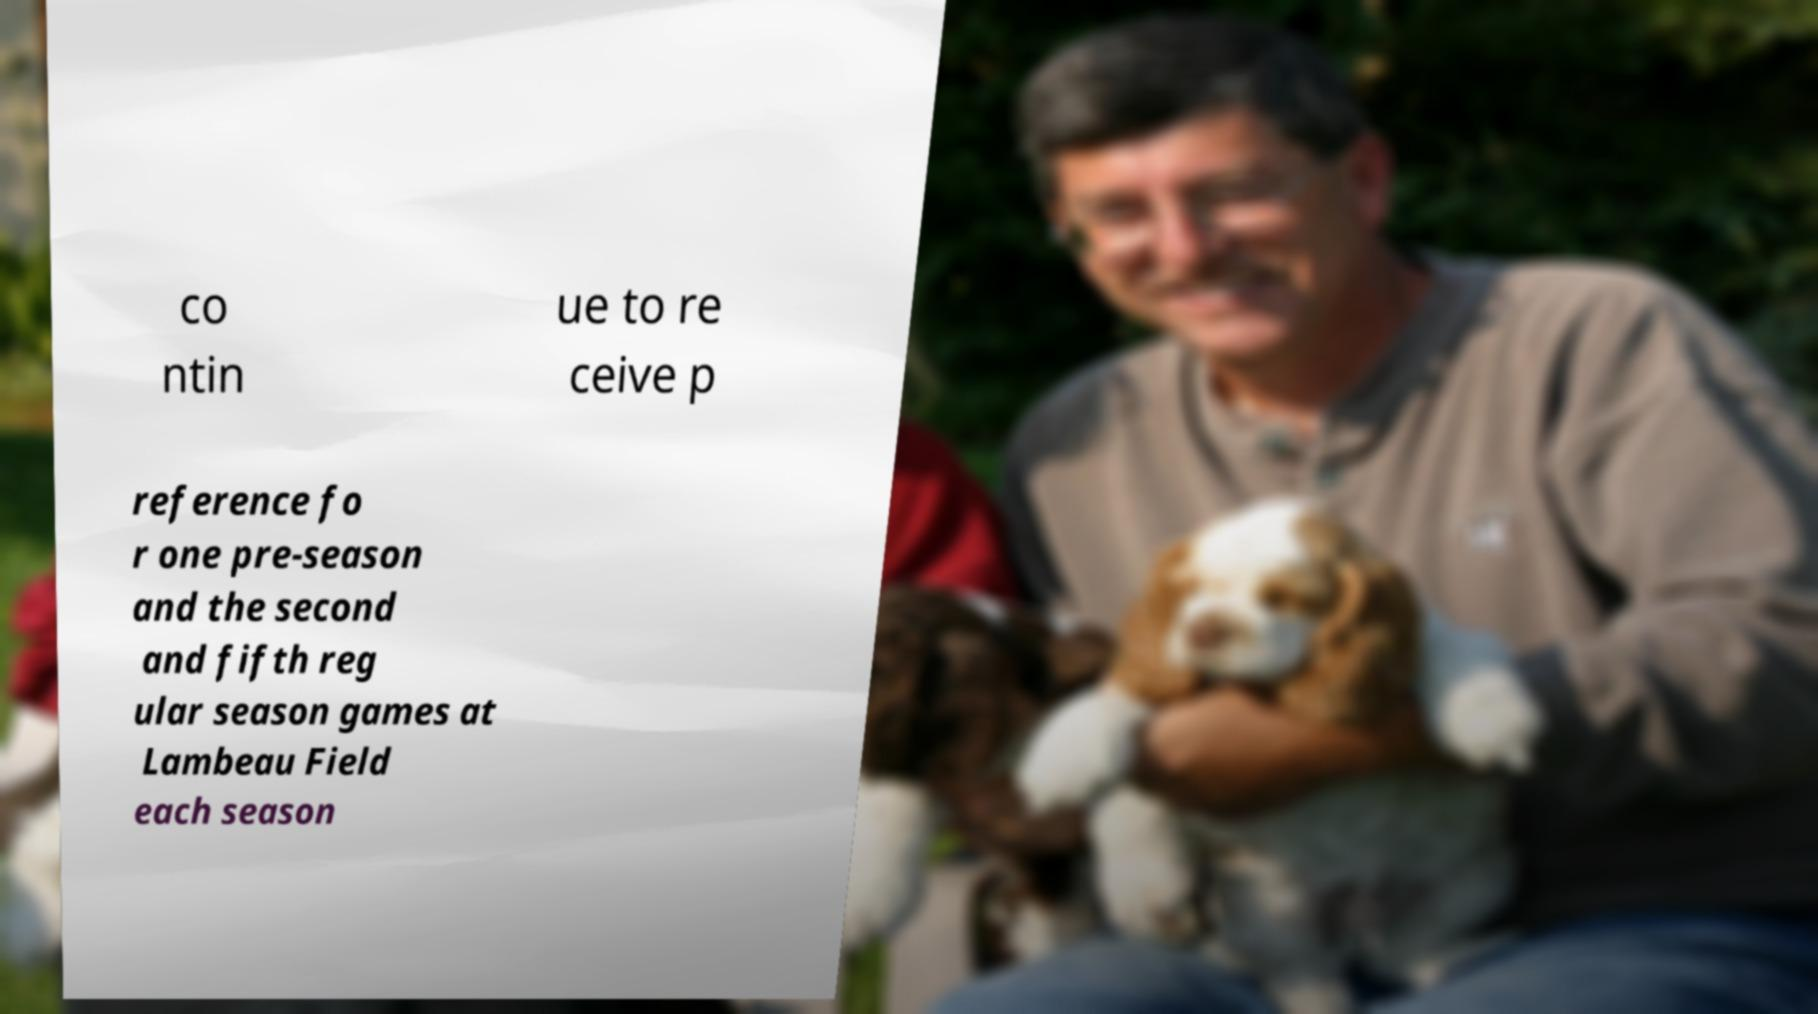What messages or text are displayed in this image? I need them in a readable, typed format. co ntin ue to re ceive p reference fo r one pre-season and the second and fifth reg ular season games at Lambeau Field each season 